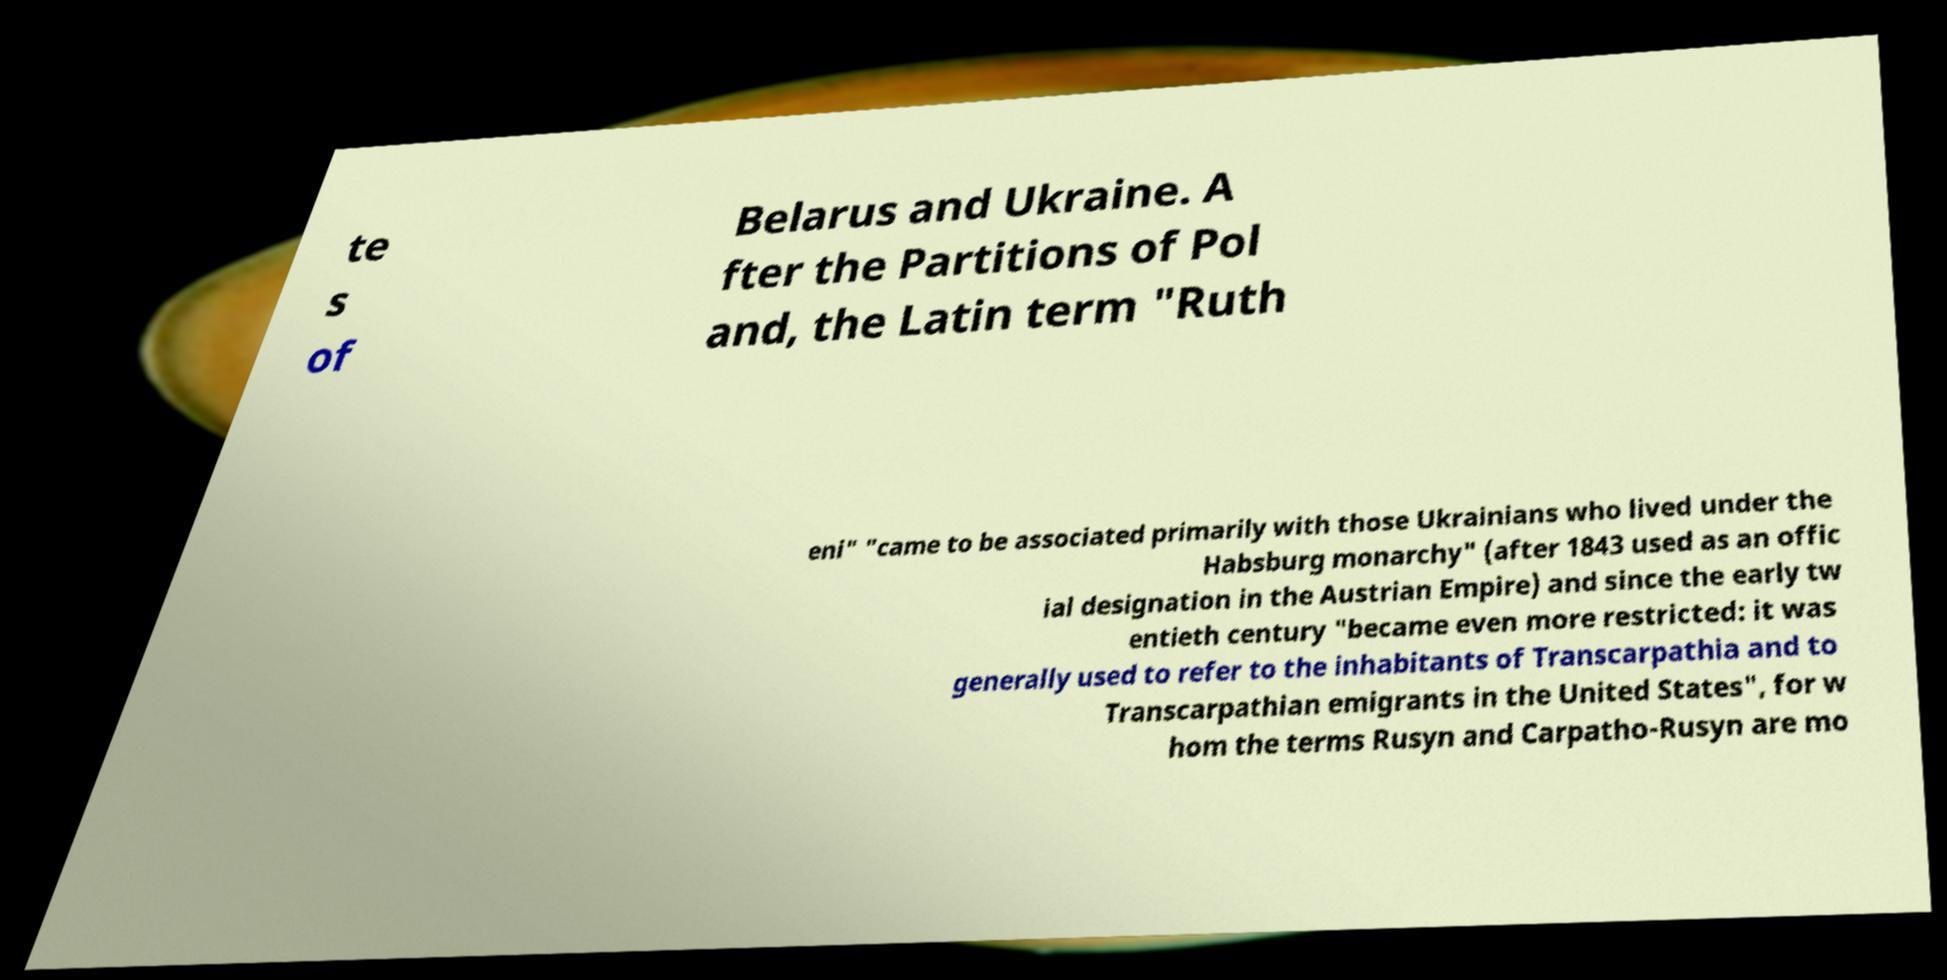Could you assist in decoding the text presented in this image and type it out clearly? te s of Belarus and Ukraine. A fter the Partitions of Pol and, the Latin term "Ruth eni" "came to be associated primarily with those Ukrainians who lived under the Habsburg monarchy" (after 1843 used as an offic ial designation in the Austrian Empire) and since the early tw entieth century "became even more restricted: it was generally used to refer to the inhabitants of Transcarpathia and to Transcarpathian emigrants in the United States", for w hom the terms Rusyn and Carpatho-Rusyn are mo 